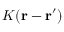Convert formula to latex. <formula><loc_0><loc_0><loc_500><loc_500>K ( r - r ^ { \prime } )</formula> 